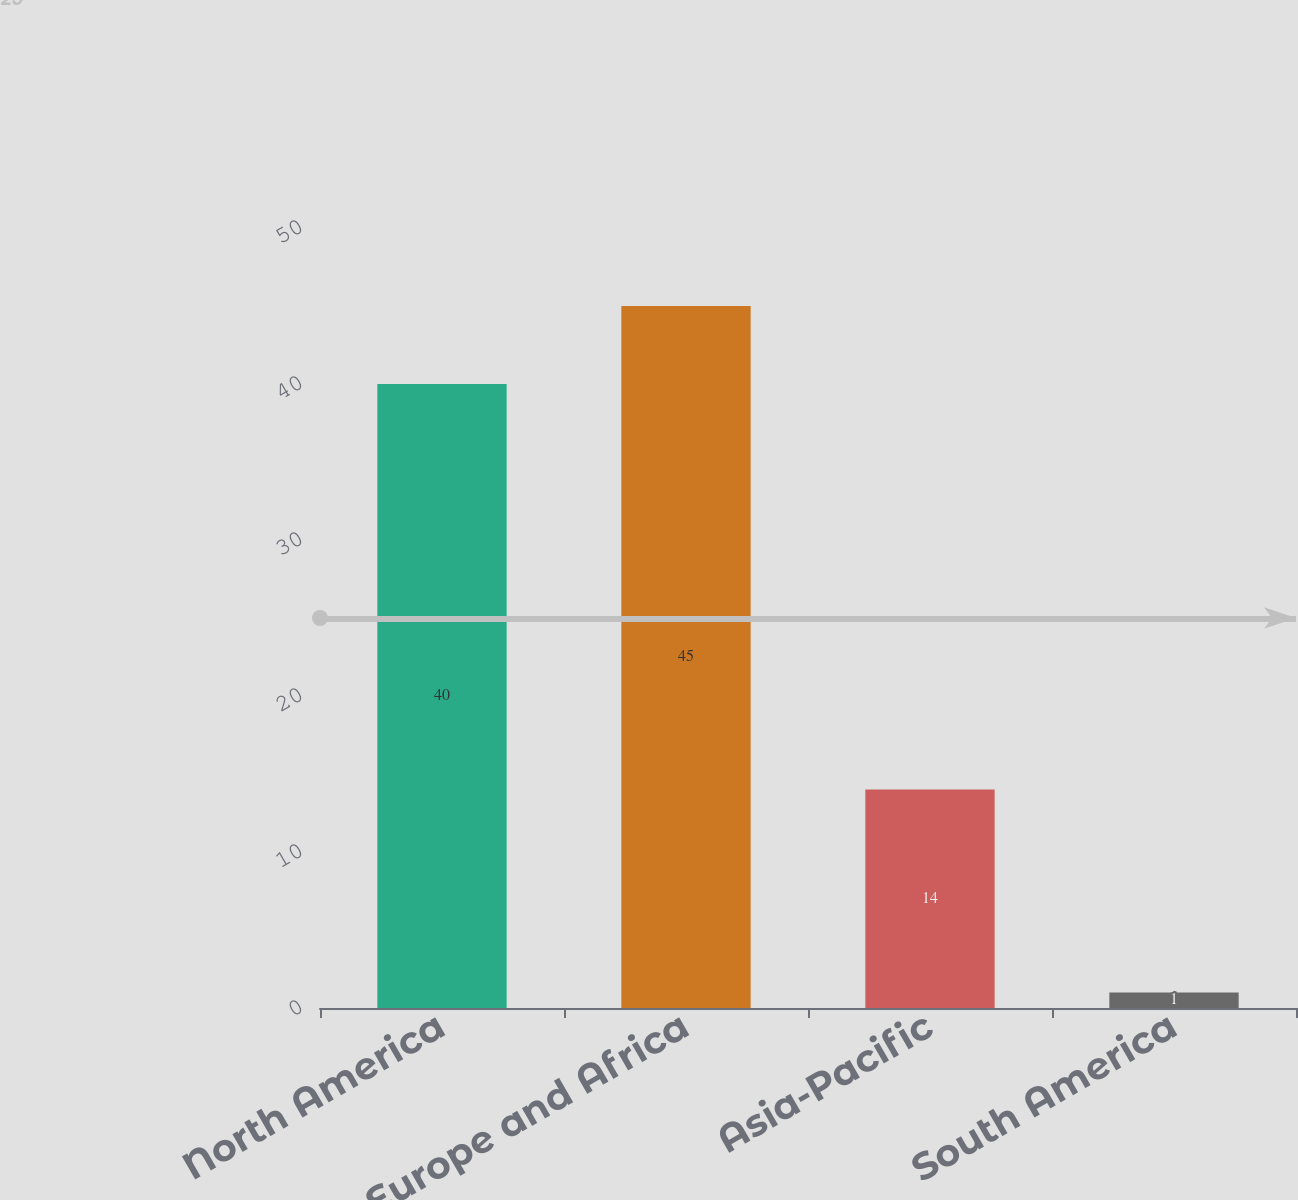Convert chart. <chart><loc_0><loc_0><loc_500><loc_500><bar_chart><fcel>North America<fcel>Europe and Africa<fcel>Asia-Pacific<fcel>South America<nl><fcel>40<fcel>45<fcel>14<fcel>1<nl></chart> 